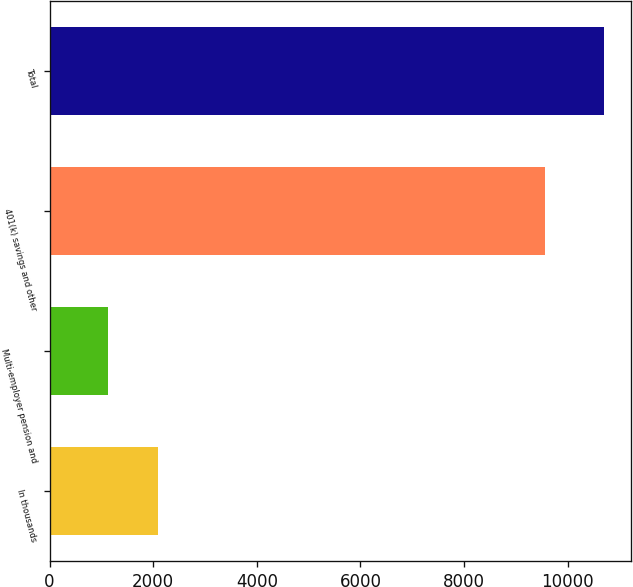<chart> <loc_0><loc_0><loc_500><loc_500><bar_chart><fcel>In thousands<fcel>Multi-employer pension and<fcel>401(k) savings and other<fcel>Total<nl><fcel>2086.7<fcel>1130<fcel>9567<fcel>10697<nl></chart> 